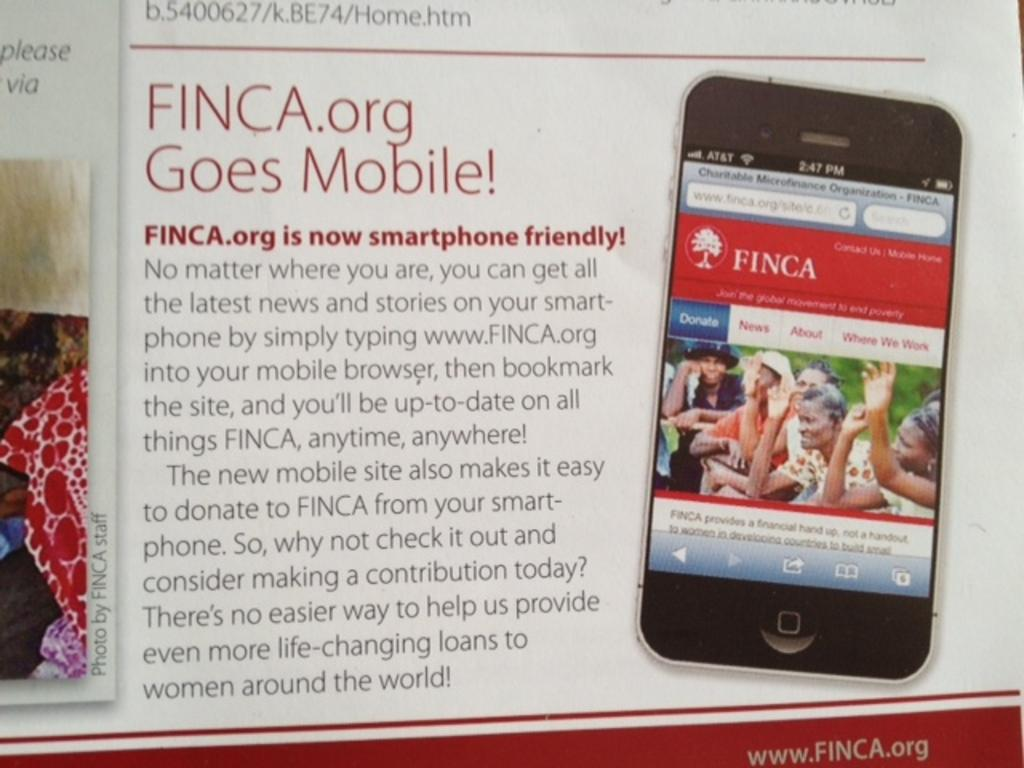<image>
Share a concise interpretation of the image provided. An advertisement concerns an organization called FINCA.org going mobile. 